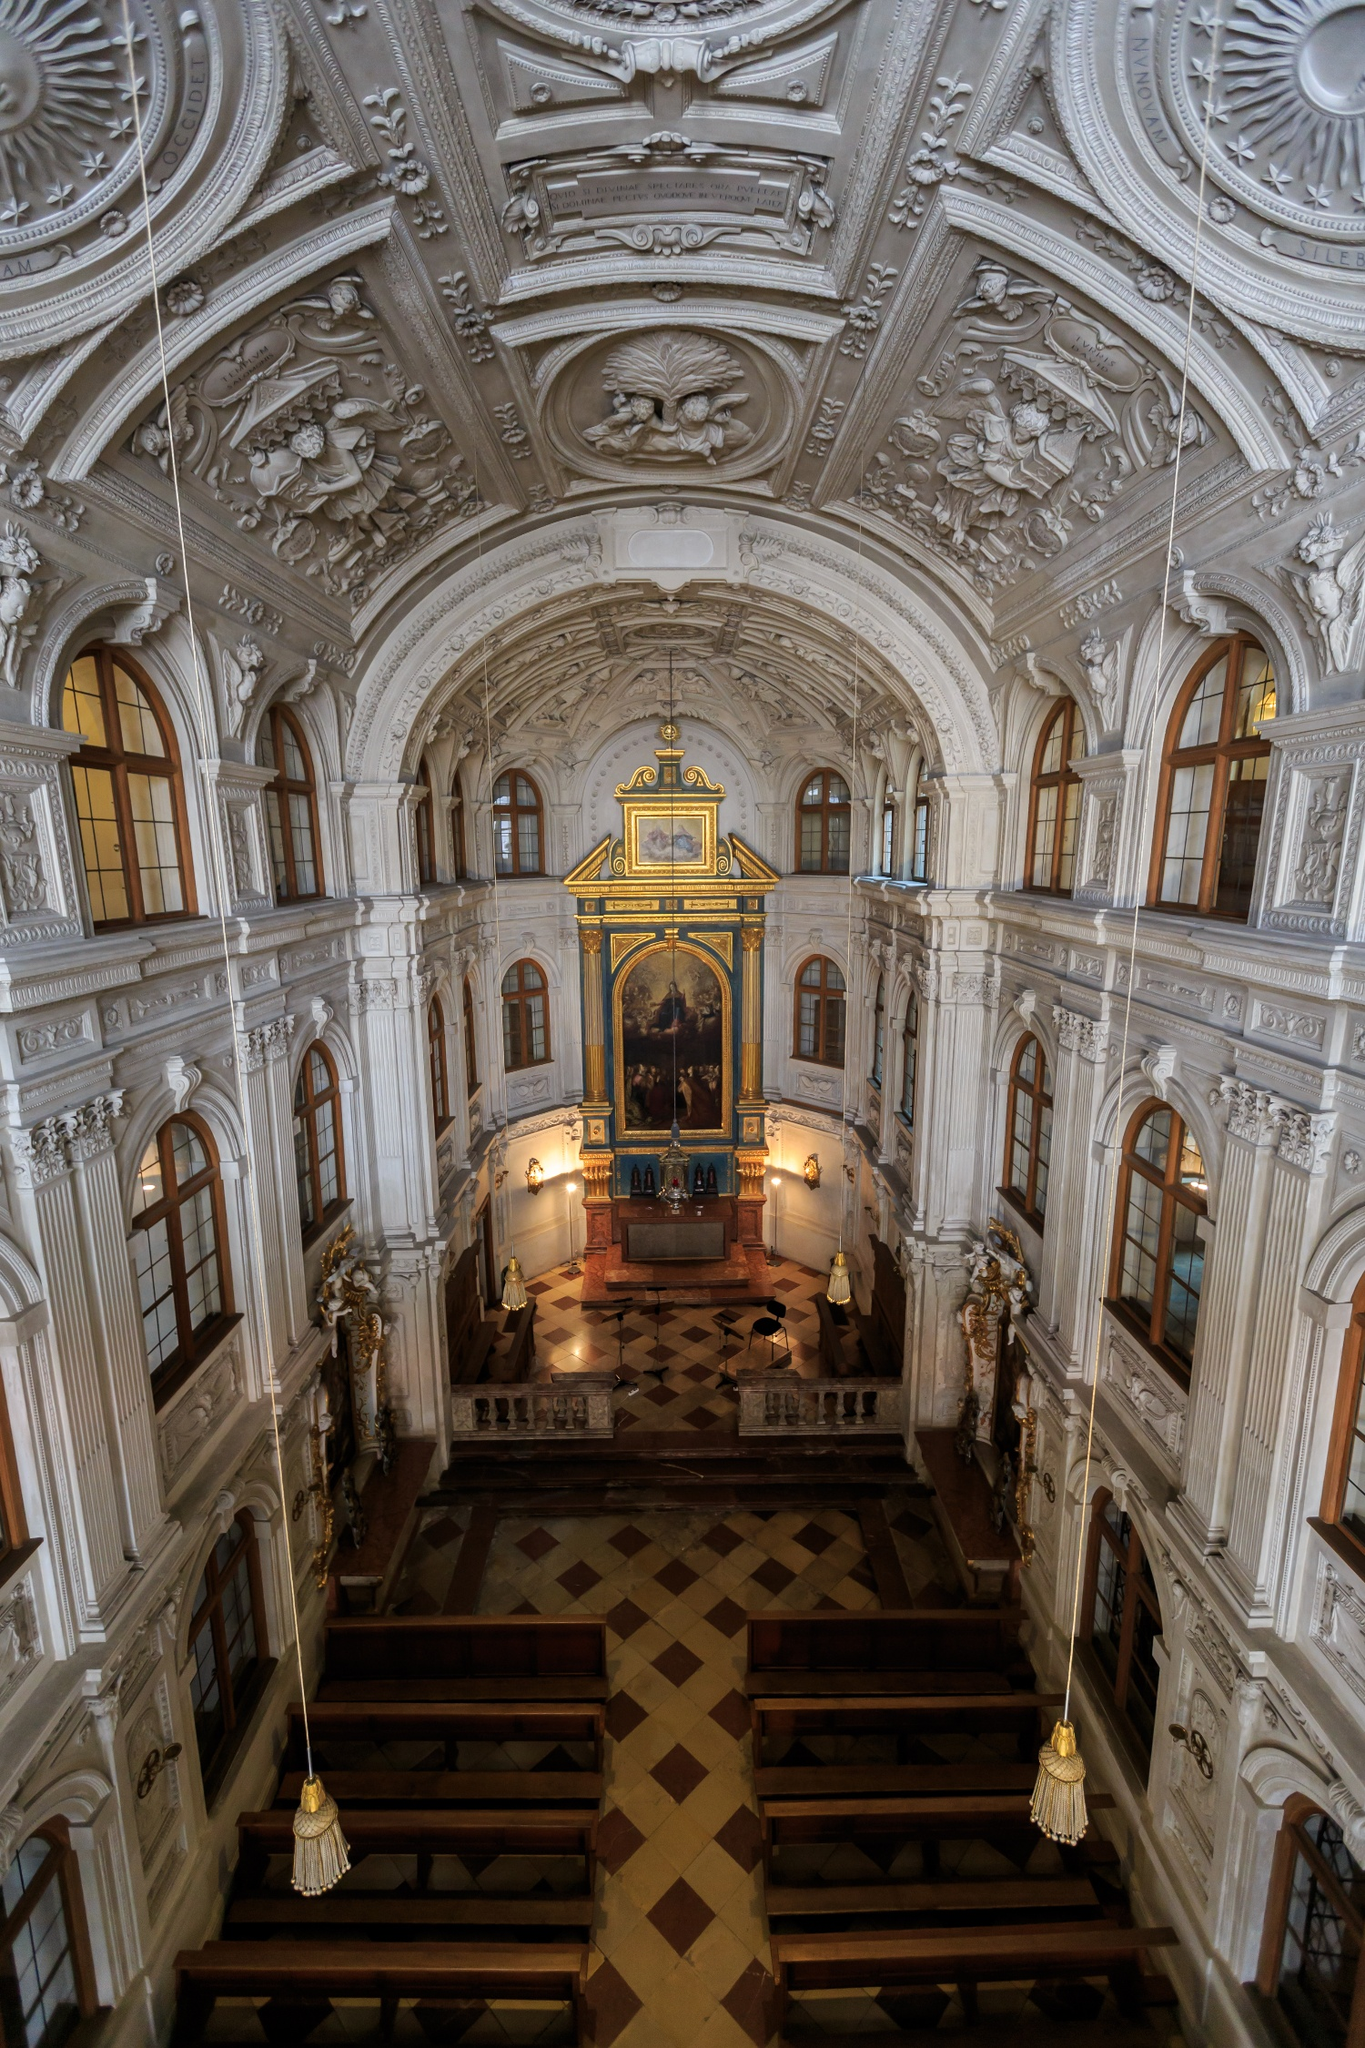Describe the following image. The image captures the awe-inspiring interior of the Hofkirche, a baroque church located in Dresden, Germany. This elevated view highlights the church's nave and altar, showcasing the exquisite baroque details that define this architectural masterpiece. The walls and ceiling are adorned with elaborate white stucco work and gilded accents, a testament to the baroque style's grandeur. The checkered marble floor adds to the opulent ambiance of the space. At the center, the altar is flanked by two imposing columns and features a breathtaking painting of the Virgin Mary holding Jesus, serving as the spiritual focal point of the interior. The soft natural light filtering through the windows enhances the serenity and majesty of this historic church. 